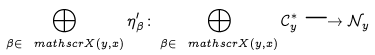<formula> <loc_0><loc_0><loc_500><loc_500>\bigoplus _ { \beta \in \ m a t h s c r { X } ( y , x ) } \eta ^ { \prime } _ { \beta } \colon \bigoplus _ { \beta \in \ m a t h s c r { X } ( y , x ) } { \mathcal { C } _ { y } ^ { * } } \longrightarrow \mathcal { N } _ { y }</formula> 